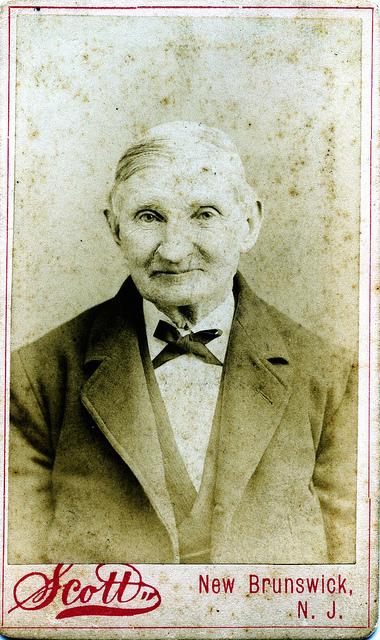What city is on the picture?
Answer briefly. New brunswick. Was the picture taken in the US?
Write a very short answer. Yes. What famous photographer took this picture?
Give a very brief answer. Scott. 